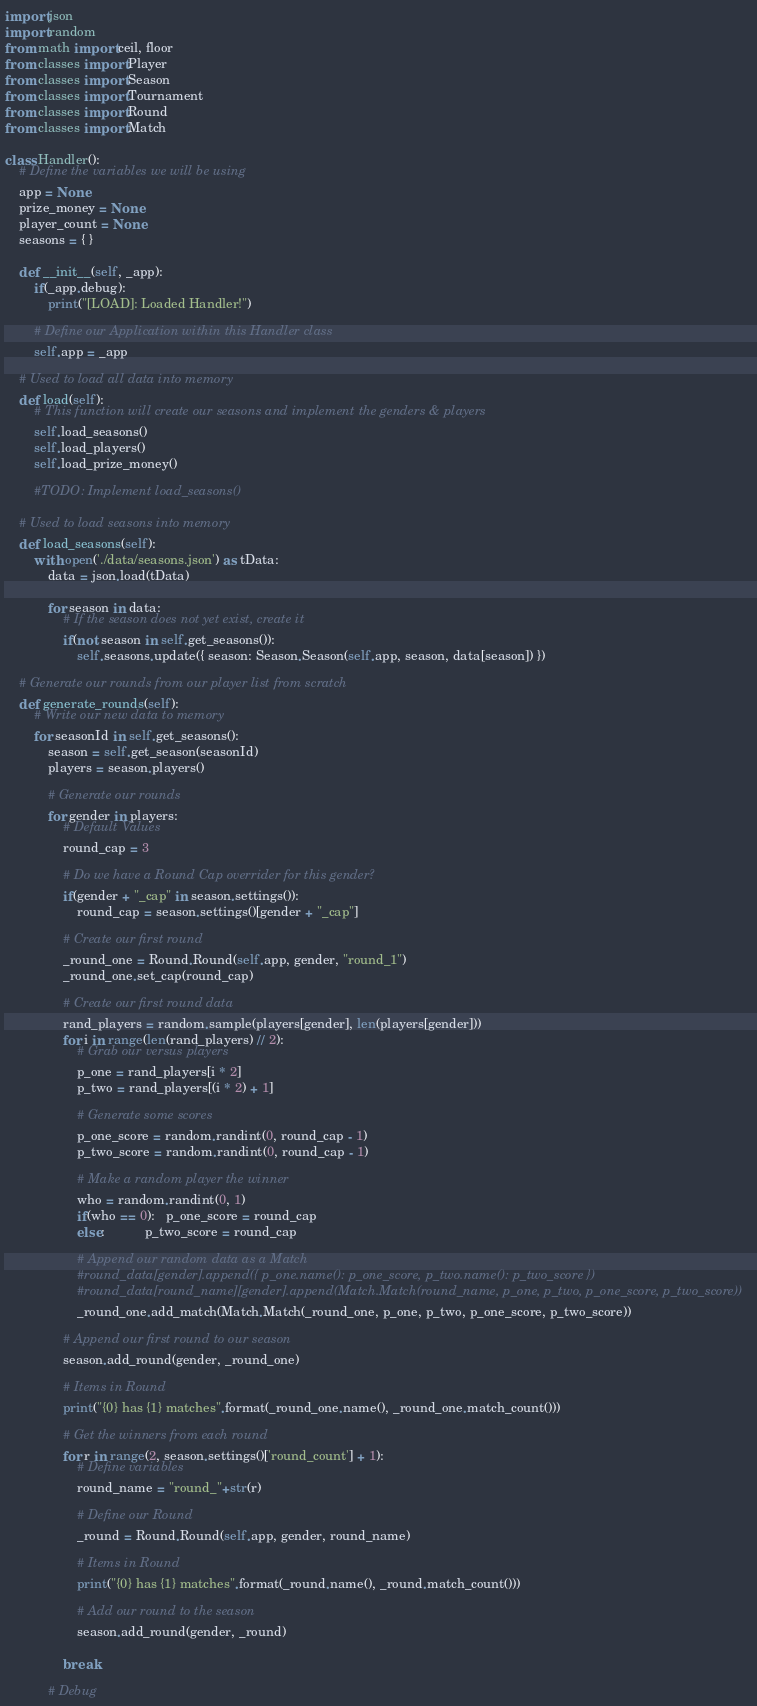<code> <loc_0><loc_0><loc_500><loc_500><_Python_>
import json
import random
from math import ceil, floor
from classes import Player
from classes import Season
from classes import Tournament
from classes import Round
from classes import Match

class Handler():
    # Define the variables we will be using
    app = None
    prize_money = None
    player_count = None
    seasons = { }

    def __init__(self, _app):
        if(_app.debug):
            print("[LOAD]: Loaded Handler!")

        # Define our Application within this Handler class
        self.app = _app

    # Used to load all data into memory
    def load(self):
        # This function will create our seasons and implement the genders & players
        self.load_seasons()
        self.load_players()
        self.load_prize_money()

        #TODO: Implement load_seasons()

    # Used to load seasons into memory
    def load_seasons(self):
        with open('./data/seasons.json') as tData:
            data = json.load(tData)

            for season in data:
                # If the season does not yet exist, create it
                if(not season in self.get_seasons()):
                    self.seasons.update({ season: Season.Season(self.app, season, data[season]) })

    # Generate our rounds from our player list from scratch
    def generate_rounds(self):
        # Write our new data to memory
        for seasonId in self.get_seasons():
            season = self.get_season(seasonId)
            players = season.players()

            # Generate our rounds
            for gender in players:
                # Default Values
                round_cap = 3

                # Do we have a Round Cap overrider for this gender?
                if(gender + "_cap" in season.settings()):
                    round_cap = season.settings()[gender + "_cap"]

                # Create our first round
                _round_one = Round.Round(self.app, gender, "round_1")
                _round_one.set_cap(round_cap)

                # Create our first round data
                rand_players = random.sample(players[gender], len(players[gender]))
                for i in range(len(rand_players) // 2):
                    # Grab our versus players
                    p_one = rand_players[i * 2]
                    p_two = rand_players[(i * 2) + 1]

                    # Generate some scores
                    p_one_score = random.randint(0, round_cap - 1)
                    p_two_score = random.randint(0, round_cap - 1)

                    # Make a random player the winner
                    who = random.randint(0, 1)
                    if(who == 0):   p_one_score = round_cap
                    else:           p_two_score = round_cap

                    # Append our random data as a Match
                    #round_data[gender].append({ p_one.name(): p_one_score, p_two.name(): p_two_score })
                    #round_data[round_name][gender].append(Match.Match(round_name, p_one, p_two, p_one_score, p_two_score))
                    _round_one.add_match(Match.Match(_round_one, p_one, p_two, p_one_score, p_two_score))

                # Append our first round to our season
                season.add_round(gender, _round_one)

                # Items in Round
                print("{0} has {1} matches".format(_round_one.name(), _round_one.match_count()))

                # Get the winners from each round
                for r in range(2, season.settings()['round_count'] + 1):
                    # Define variables
                    round_name = "round_"+str(r)

                    # Define our Round
                    _round = Round.Round(self.app, gender, round_name)

                    # Items in Round
                    print("{0} has {1} matches".format(_round.name(), _round.match_count()))

                    # Add our round to the season
                    season.add_round(gender, _round)

                break
            
            # Debug</code> 